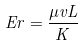<formula> <loc_0><loc_0><loc_500><loc_500>E r = { \frac { \mu v L } { K } }</formula> 